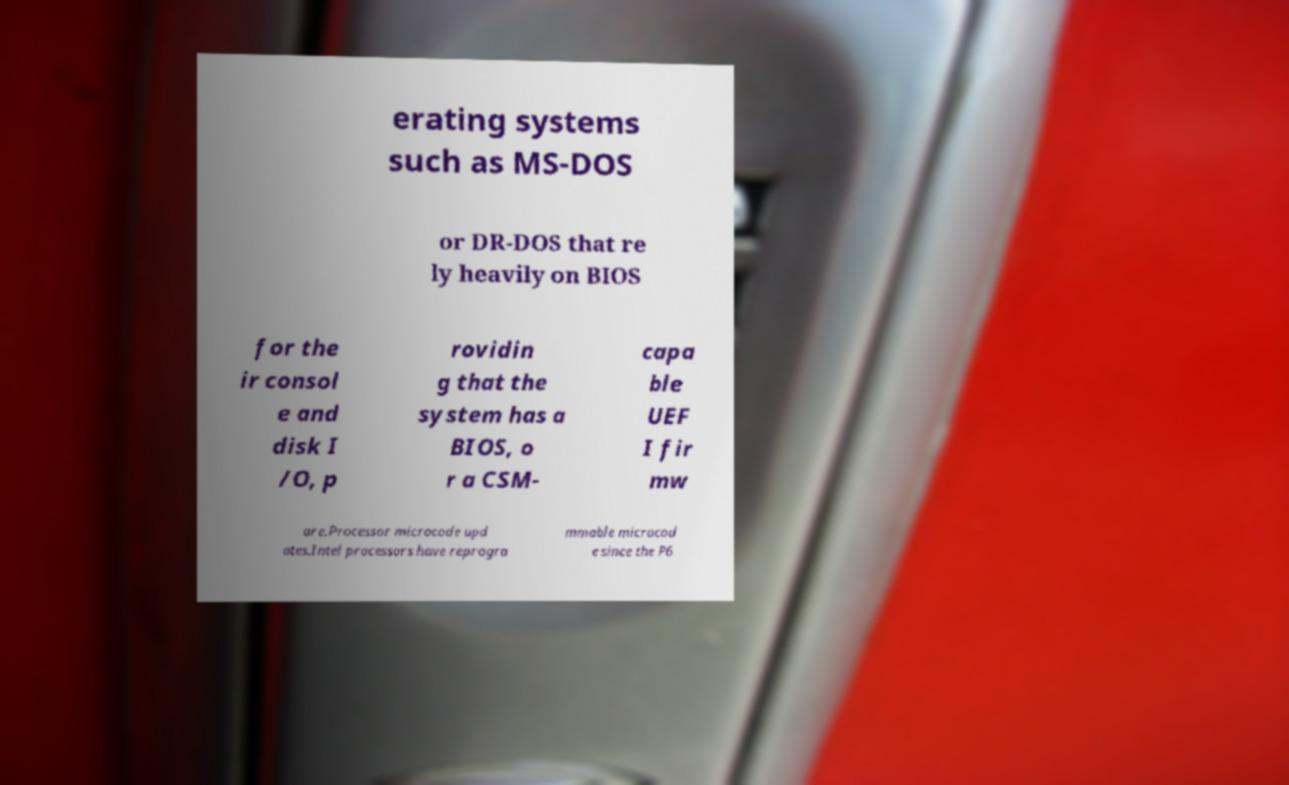There's text embedded in this image that I need extracted. Can you transcribe it verbatim? erating systems such as MS-DOS or DR-DOS that re ly heavily on BIOS for the ir consol e and disk I /O, p rovidin g that the system has a BIOS, o r a CSM- capa ble UEF I fir mw are.Processor microcode upd ates.Intel processors have reprogra mmable microcod e since the P6 